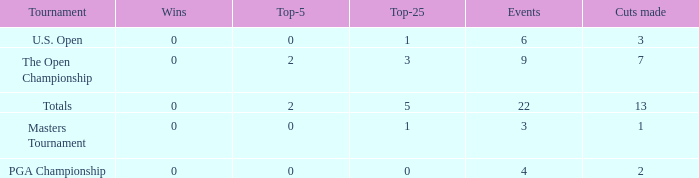What is the total number of wins for events with under 2 top-5s, under 5 top-25s, and more than 4 events played? 1.0. 